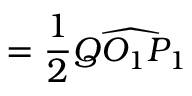<formula> <loc_0><loc_0><loc_500><loc_500>= { \frac { 1 } { 2 } } { \widehat { Q O _ { 1 } P _ { 1 } } }</formula> 